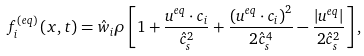<formula> <loc_0><loc_0><loc_500><loc_500>f _ { i } ^ { \left ( { e q } \right ) } \left ( { { x } , t } \right ) = { { \hat { w } } _ { i } } \rho \left [ { 1 + \frac { { { { u } ^ { e q } } \cdot { { c } _ { i } } } } { \hat { c } _ { s } ^ { 2 } } + \frac { { { { \left ( { { { u } ^ { e q } } \cdot { { c } _ { i } } } \right ) } ^ { 2 } } } } { 2 \hat { c } _ { s } ^ { 4 } } - \frac { { \left | { { { u } ^ { e q } } } \right | } } { 2 \hat { c } _ { s } ^ { 2 } } } \right ] ,</formula> 